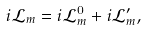Convert formula to latex. <formula><loc_0><loc_0><loc_500><loc_500>i { \mathcal { L } } _ { m } = i { \mathcal { L } } _ { m } ^ { 0 } + i { \mathcal { L } } _ { m } ^ { \prime } ,</formula> 